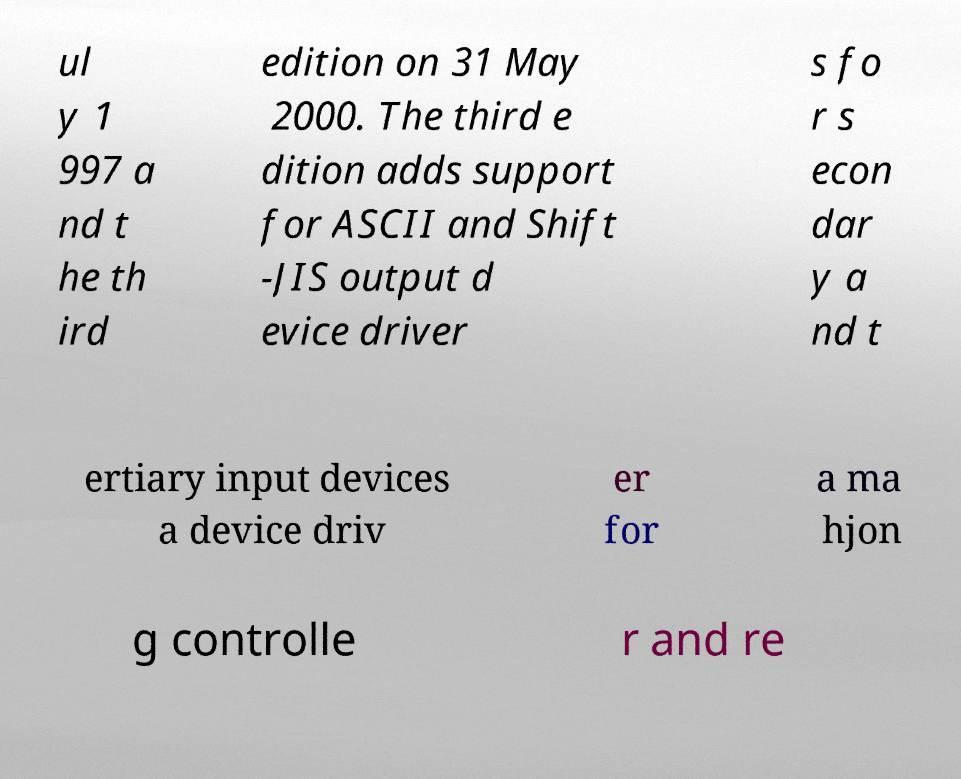Can you accurately transcribe the text from the provided image for me? ul y 1 997 a nd t he th ird edition on 31 May 2000. The third e dition adds support for ASCII and Shift -JIS output d evice driver s fo r s econ dar y a nd t ertiary input devices a device driv er for a ma hjon g controlle r and re 